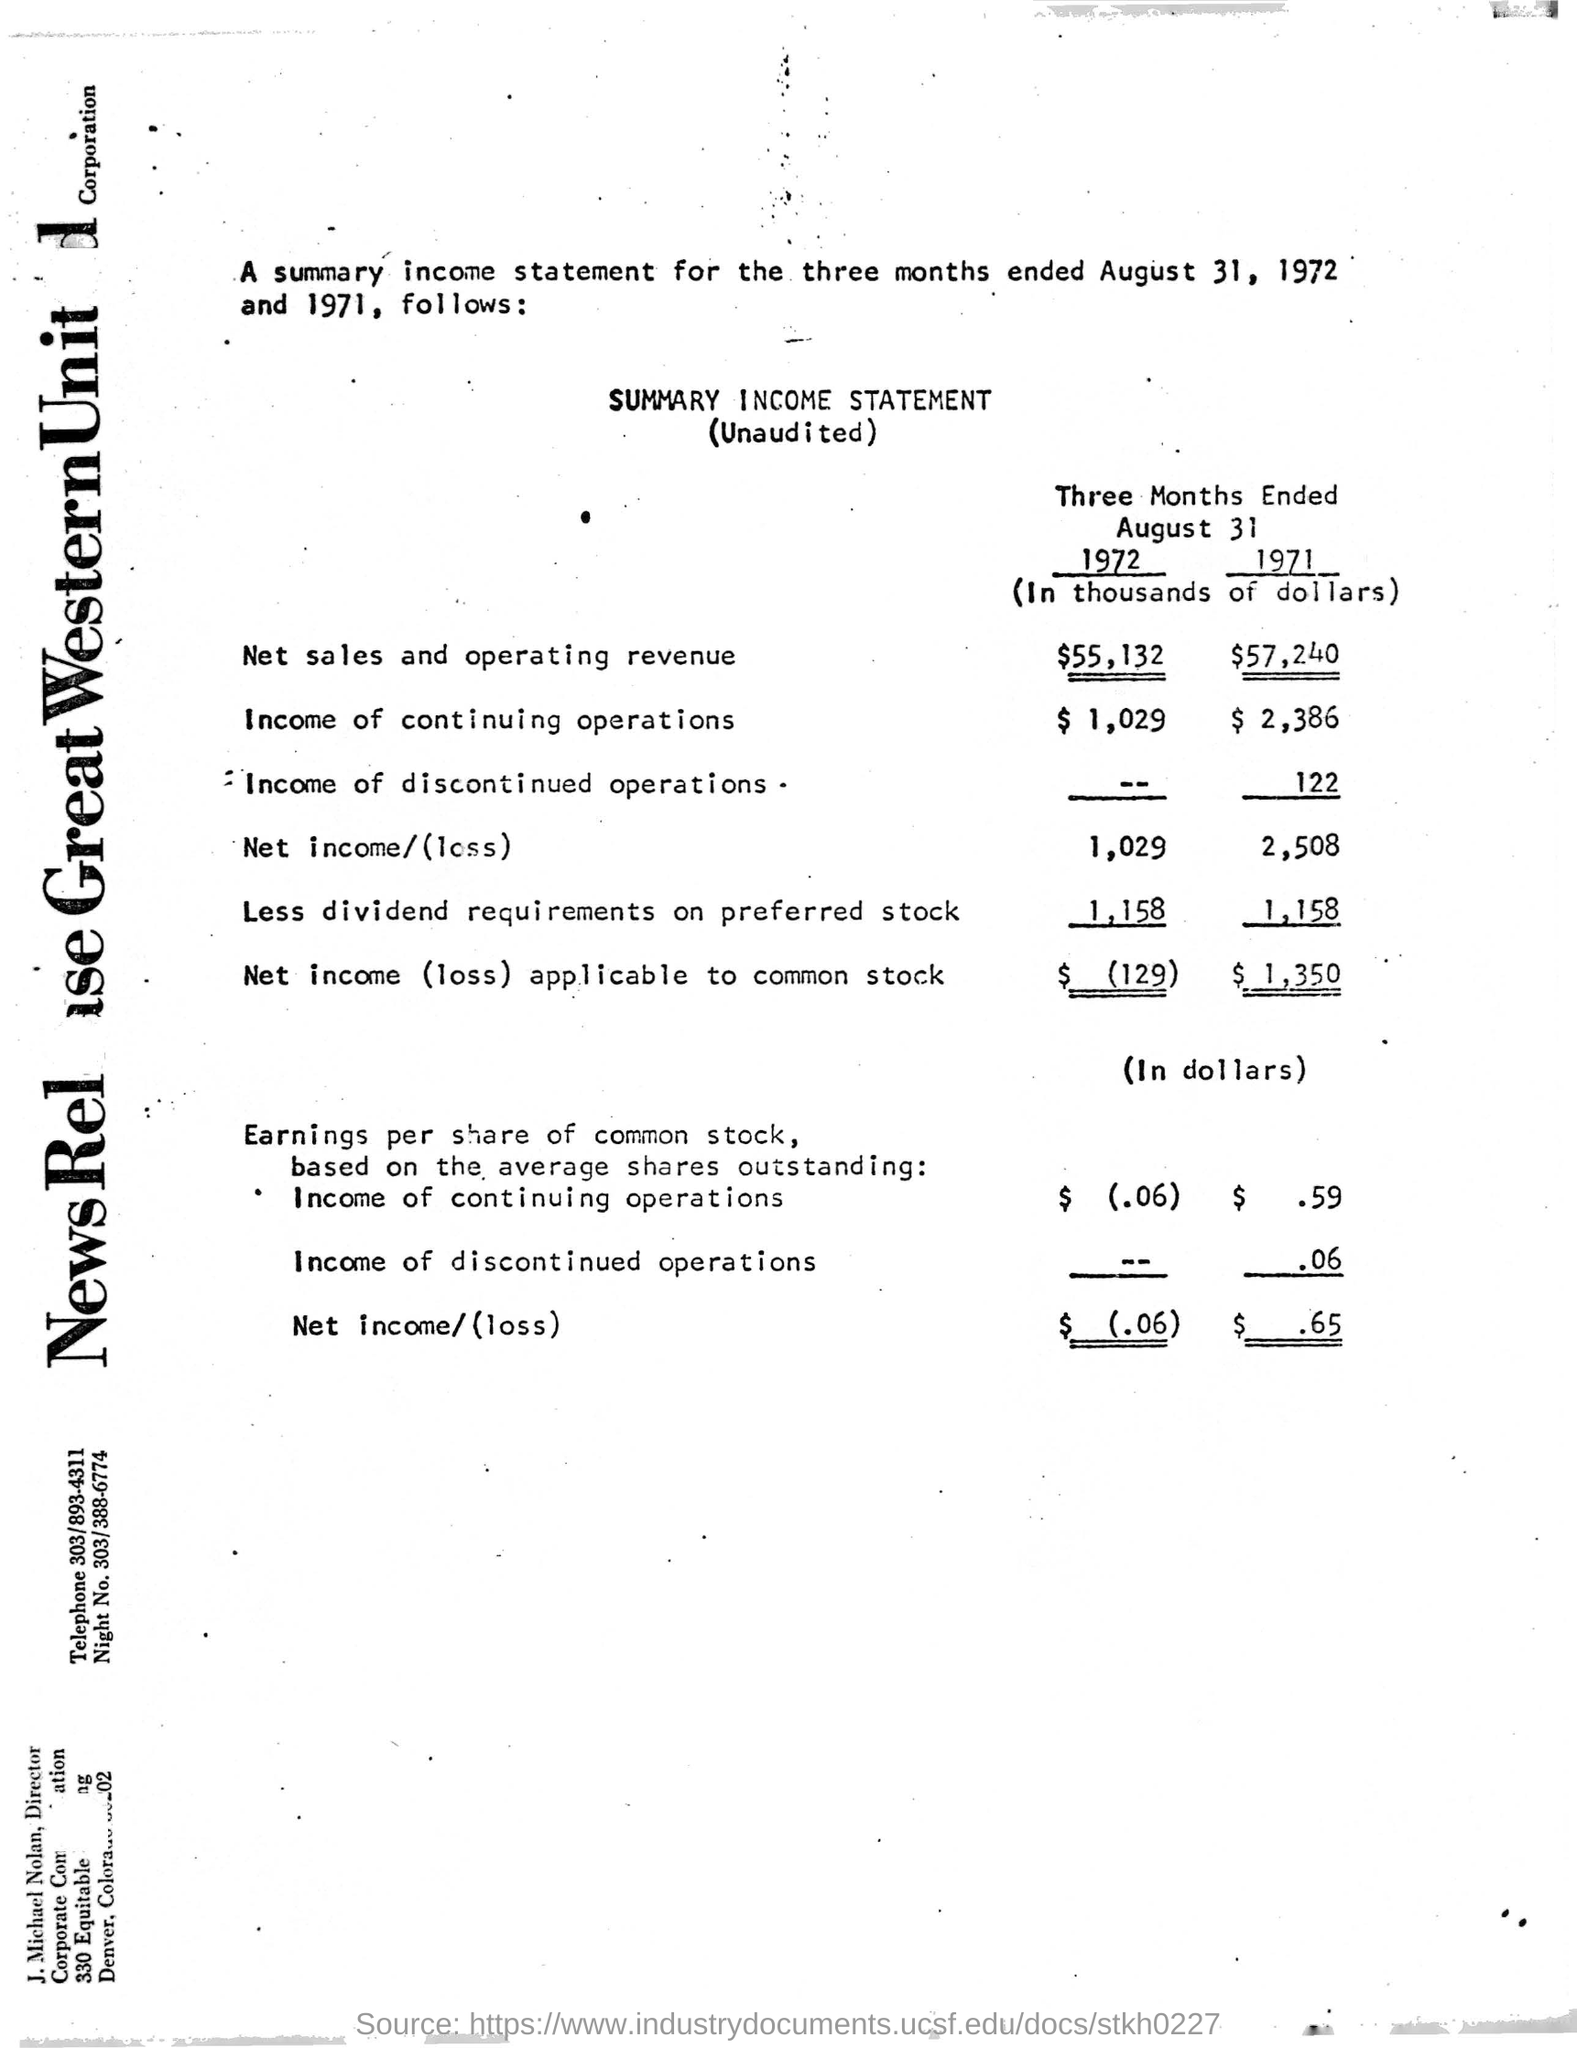What type of statement is given here?
Ensure brevity in your answer.  SUMMARY INCOME STATEMENT (Unaudited). What is the net sales and operating revenue for the three months ended August 31, 1972?
Provide a short and direct response. $55,132. What is the income of continuing operations for the three months ended August 31, 1972?
Provide a short and direct response. $ 1,029. What is the net sales and operating revenue for the three months ended August 31, 1971?
Provide a succinct answer. $57,240. What is the net income (loss) applicable to common stock for the three months ended August 31, 1971?
Your answer should be very brief. $1,350. What is the income of continuing operations for the three months ended August 31, 1971?
Your answer should be very brief. $ 2,386. 